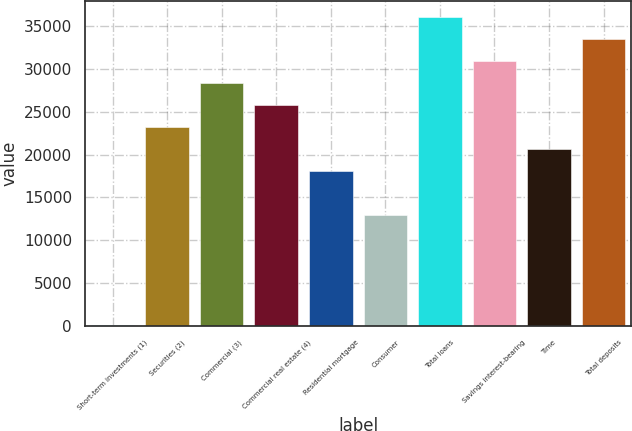Convert chart. <chart><loc_0><loc_0><loc_500><loc_500><bar_chart><fcel>Short-term investments (1)<fcel>Securities (2)<fcel>Commercial (3)<fcel>Commercial real estate (4)<fcel>Residential mortgage<fcel>Consumer<fcel>Total loans<fcel>Savings interest-bearing<fcel>Time<fcel>Total deposits<nl><fcel>156.1<fcel>23255<fcel>28388<fcel>25821.5<fcel>18121.9<fcel>12988.8<fcel>36087.7<fcel>30954.6<fcel>20688.4<fcel>33521.1<nl></chart> 